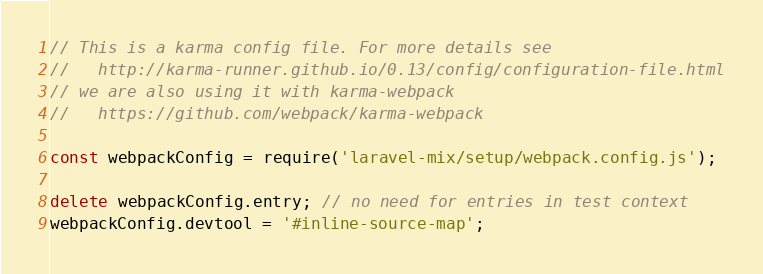<code> <loc_0><loc_0><loc_500><loc_500><_JavaScript_>// This is a karma config file. For more details see
//   http://karma-runner.github.io/0.13/config/configuration-file.html
// we are also using it with karma-webpack
//   https://github.com/webpack/karma-webpack

const webpackConfig = require('laravel-mix/setup/webpack.config.js');

delete webpackConfig.entry; // no need for entries in test context
webpackConfig.devtool = '#inline-source-map';
</code> 